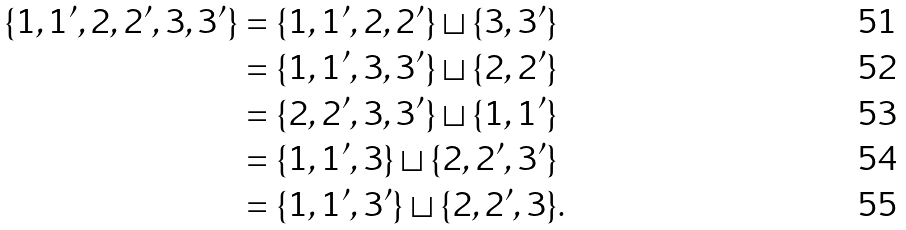<formula> <loc_0><loc_0><loc_500><loc_500>\{ 1 , 1 ^ { \prime } , 2 , 2 ^ { \prime } , 3 , 3 ^ { \prime } \} & = \{ 1 , 1 ^ { \prime } , 2 , 2 ^ { \prime } \} \sqcup \{ 3 , 3 ^ { \prime } \} \\ & = \{ 1 , 1 ^ { \prime } , 3 , 3 ^ { \prime } \} \sqcup \{ 2 , 2 ^ { \prime } \} \\ & = \{ 2 , 2 ^ { \prime } , 3 , 3 ^ { \prime } \} \sqcup \{ 1 , 1 ^ { \prime } \} \\ & = \{ 1 , 1 ^ { \prime } , 3 \} \sqcup \{ 2 , 2 ^ { \prime } , 3 ^ { \prime } \} \\ & = \{ 1 , 1 ^ { \prime } , 3 ^ { \prime } \} \sqcup \{ 2 , 2 ^ { \prime } , 3 \} .</formula> 